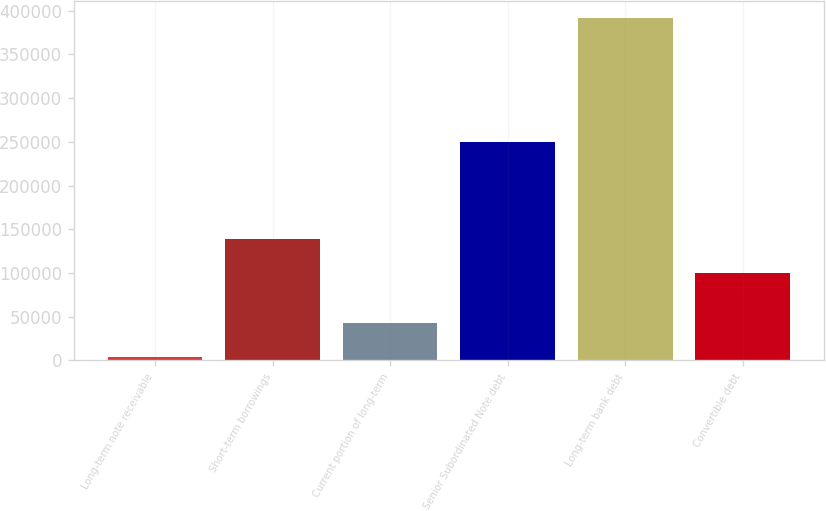<chart> <loc_0><loc_0><loc_500><loc_500><bar_chart><fcel>Long-term note receivable<fcel>Short-term borrowings<fcel>Current portion of long-term<fcel>Senior Subordinated Note debt<fcel>Long-term bank debt<fcel>Convertible debt<nl><fcel>3670<fcel>138688<fcel>42409.9<fcel>250000<fcel>391069<fcel>99948<nl></chart> 